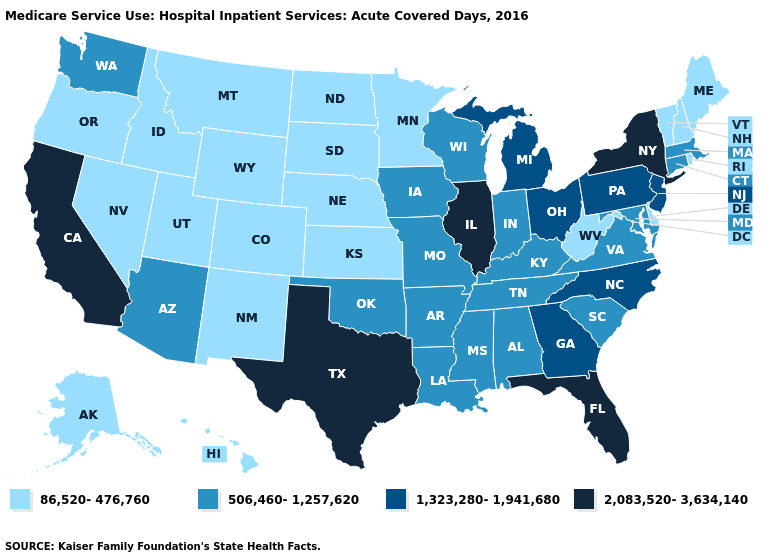Name the states that have a value in the range 2,083,520-3,634,140?
Short answer required. California, Florida, Illinois, New York, Texas. Which states have the highest value in the USA?
Be succinct. California, Florida, Illinois, New York, Texas. What is the value of Nebraska?
Be succinct. 86,520-476,760. Among the states that border Oregon , which have the lowest value?
Give a very brief answer. Idaho, Nevada. What is the value of Illinois?
Keep it brief. 2,083,520-3,634,140. Does New Jersey have the lowest value in the Northeast?
Quick response, please. No. Among the states that border Louisiana , does Texas have the highest value?
Short answer required. Yes. Among the states that border West Virginia , which have the highest value?
Answer briefly. Ohio, Pennsylvania. Which states have the highest value in the USA?
Be succinct. California, Florida, Illinois, New York, Texas. What is the value of Arkansas?
Answer briefly. 506,460-1,257,620. Does California have the highest value in the USA?
Answer briefly. Yes. Among the states that border Oklahoma , which have the lowest value?
Be succinct. Colorado, Kansas, New Mexico. What is the value of North Carolina?
Answer briefly. 1,323,280-1,941,680. What is the value of Tennessee?
Keep it brief. 506,460-1,257,620. 